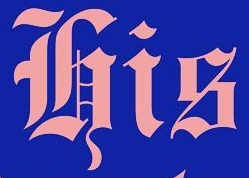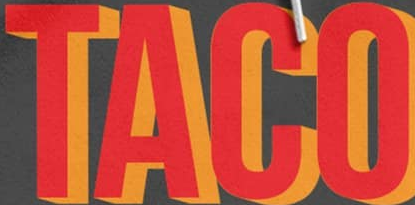What text appears in these images from left to right, separated by a semicolon? His; TACO 